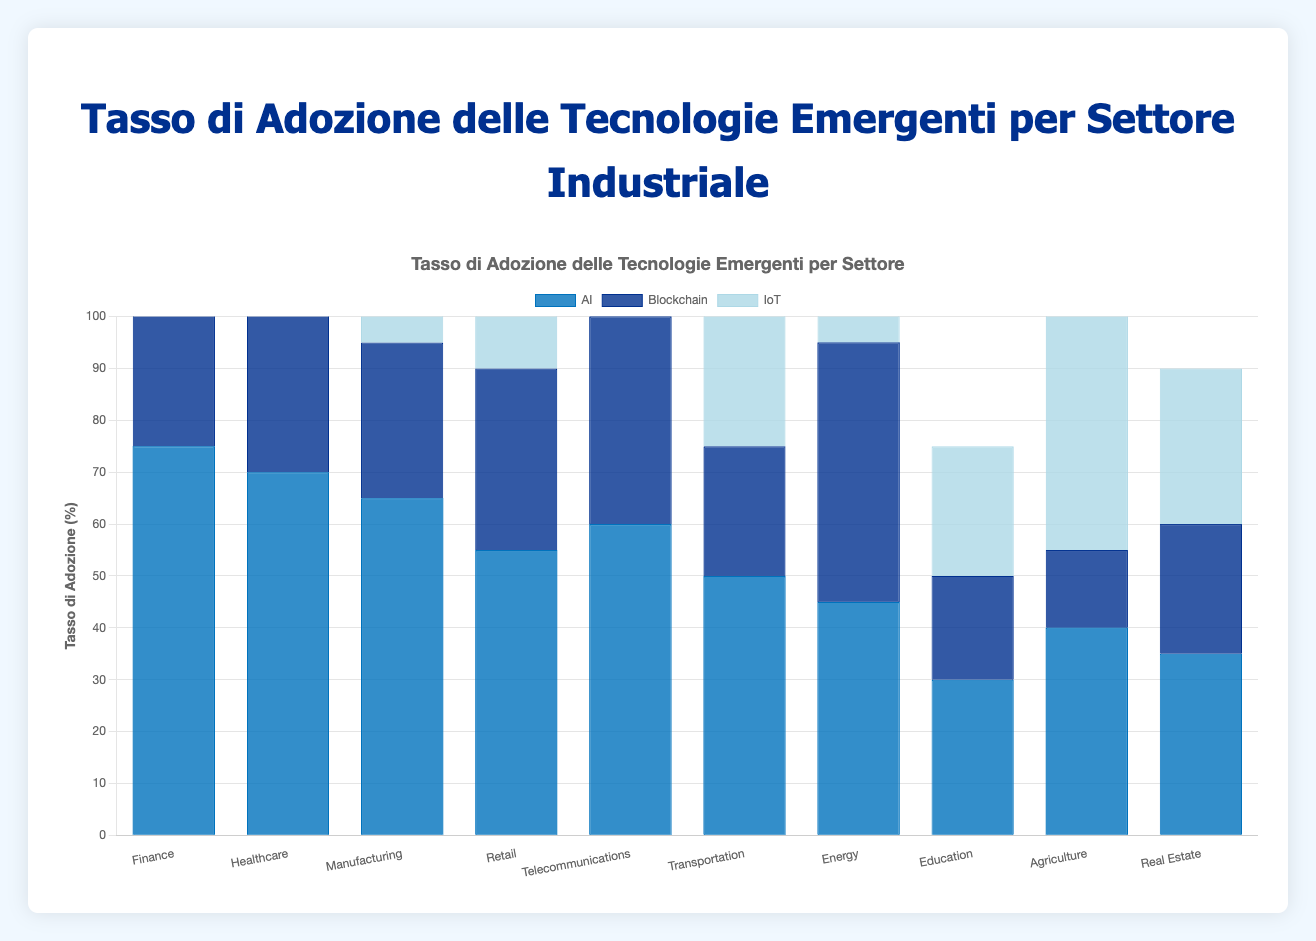Which industry has the highest AI adoption rate? By looking at the figure, we observe that the Finance industry has the highest AI adoption rate, represented by the tallest bar among all industries for the AI category.
Answer: Finance How does the IoT adoption rate in the Telecommunications industry compare with the IoT adoption rate in the Transportation industry? In the figure, the IoT adoption rate for Telecommunications is represented by a dark blue bar slightly shorter than the bar for Transportation. Therefore, the IoT adoption rate in Telecommunications is lower than in Transportation.
Answer: The IoT adoption rate in Telecommunications is lower than in Transportation Calculate the average AI adoption rate across all industries. To find the average AI adoption rate, sum the AI adoption rates across all industries (75 + 70 + 65 + 55 + 60 + 50 + 45 + 30 + 40 + 35) = 525, and then divide by the number of industries (10). The average is 525/10 = 52.5.
Answer: 52.5 Between Finance and Healthcare, which has a higher blockchain adoption rate, and by how much? By referring to the figure, the Blockchain adoption rate for Finance is 60, and for Healthcare, it is 45. The difference is 60 - 45 = 15.
Answer: Finance by 15 What is the combined adoption rate of AI and Blockchain in the Manufacturing industry? For Manufacturing, the AI adoption rate is 65, and the Blockchain adoption rate is 30. Summing them up gives 65 + 30 = 95.
Answer: 95 Identify the industry with the lowest adoption rate for IoT. The figure shows the lowest dark blue bar for IoT in the Education industry, indicating it has the lowest IoT adoption rate at 25%.
Answer: Education How much higher is the IoT adoption rate in Energy than in Real Estate? According to the figure, the IoT adoption rate in Energy is 60%, while in Real Estate it is 30%. The difference is 60 - 30 = 30.
Answer: 30 Which technology has the highest overall adoption rate, and in which industry is this observed? The highest overall adoption rate is observed in the IoT category in the Transportation industry, represented by the tallest dark blue bar for any individual technology across all industries at 80%.
Answer: IoT in Transportation What is the total adoption rate for all technologies in Agriculture? Adding the adoption rates for AI (40%), Blockchain (15%), and IoT (55%) in Agriculture, gives 40 + 15 + 55 = 110.
Answer: 110 Is the AI adoption rate in Telecommunications greater than the Blockchain adoption rate in Healthcare? The AI adoption rate in Telecommunications is 60%, while the Blockchain adoption rate in Healthcare is 45%. Since 60% is greater than 45%, the AI adoption rate in Telecommunications is indeed higher.
Answer: Yes 